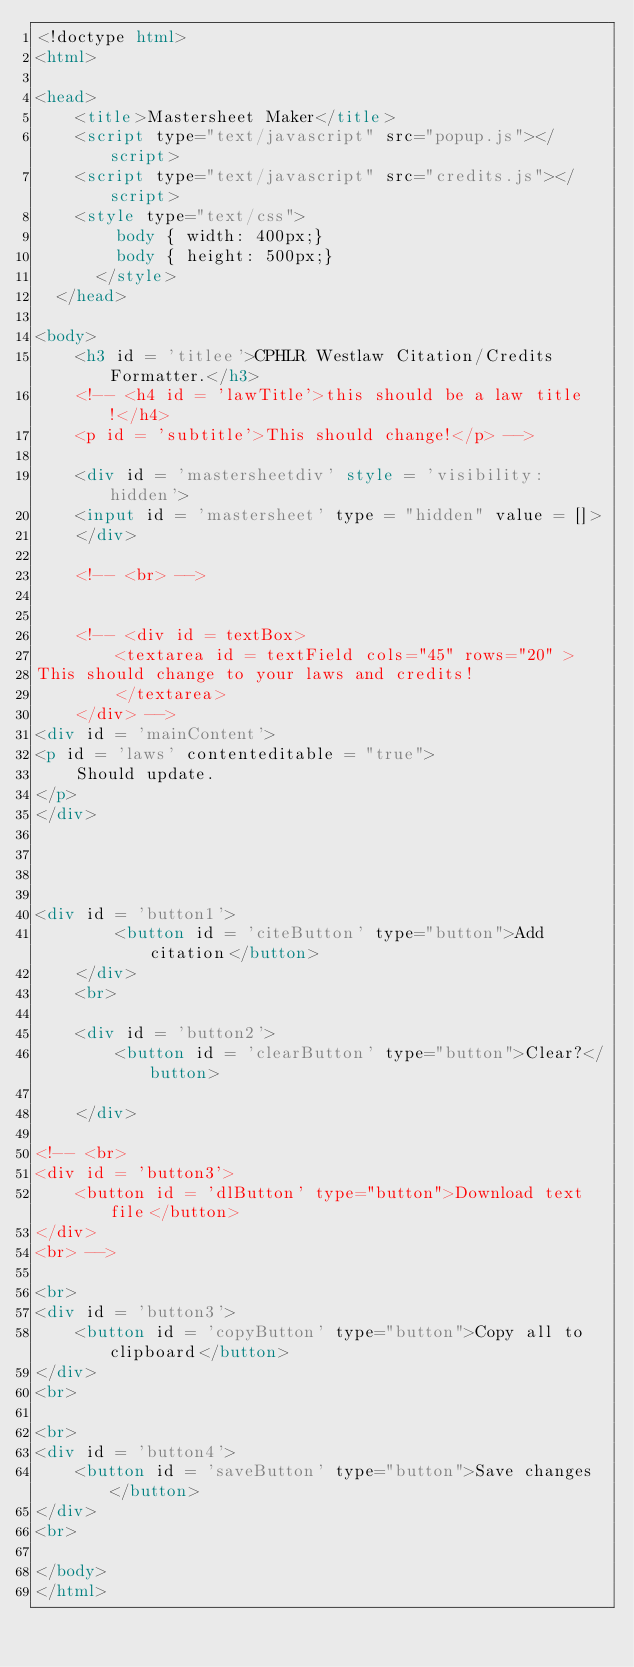Convert code to text. <code><loc_0><loc_0><loc_500><loc_500><_HTML_><!doctype html>
<html>

<head>
	<title>Mastersheet Maker</title>
	<script type="text/javascript" src="popup.js"></script>
	<script type="text/javascript" src="credits.js"></script>
    <style type="text/css">
		body { width: 400px;}
		body { height: 500px;}
	  </style>
  </head>

<body>
	<h3 id = 'titlee'>CPHLR Westlaw Citation/Credits Formatter.</h3>
	<!-- <h4 id = 'lawTitle'>this should be a law title!</h4>
	<p id = 'subtitle'>This should change!</p> -->
	
	<div id = 'mastersheetdiv' style = 'visibility: hidden'> 
	<input id = 'mastersheet' type = "hidden" value = []>
	</div>

	<!-- <br> -->


	<!-- <div id = textBox>
		<textarea id = textField cols="45" rows="20" >
This should change to your laws and credits!
		</textarea>
	</div> -->
<div id = 'mainContent'>
<p id = 'laws' contenteditable = "true">
	Should update.
</p>
</div>




<div id = 'button1'>
		<button id = 'citeButton' type="button">Add citation</button>
	</div>	
	<br>

	<div id = 'button2'>
		<button id = 'clearButton' type="button">Clear?</button>

	</div>

<!-- <br>
<div id = 'button3'>
	<button id = 'dlButton' type="button">Download text file</button>
</div>
<br> -->

<br>
<div id = 'button3'>
	<button id = 'copyButton' type="button">Copy all to clipboard</button>
</div>
<br>

<br>
<div id = 'button4'>
	<button id = 'saveButton' type="button">Save changes</button>
</div>
<br>

</body>
</html></code> 